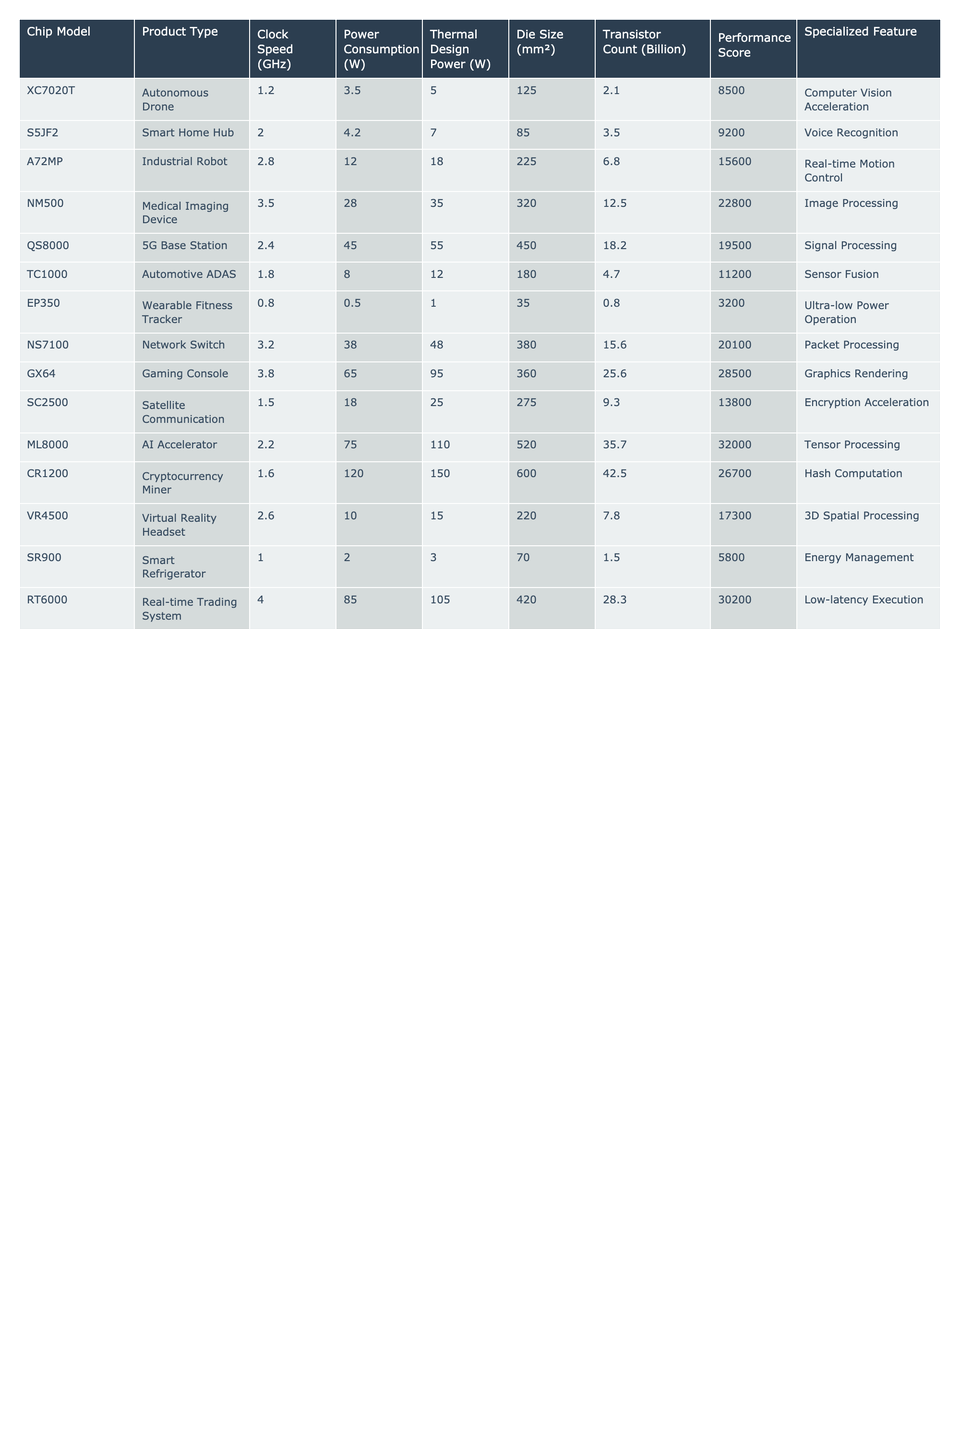What is the highest Performance Score among the chip models? The Performance Score for each chip model can be found in the table. Scanning through the rows, the highest value is 32000 for the ML8000 AI Accelerator.
Answer: 32000 Which chip model has the lowest Power Consumption? Checking the Power Consumption column reveals that the EP350 Wearable Fitness Tracker has the lowest value at 0.5 W.
Answer: 0.5 W How many chip models have a Clock Speed greater than 2.5 GHz? By counting the Clock Speed values in the table, we see that there are three models (NM500 at 3.5 GHz, QS8000 at 2.4 GHz, and GX64 at 3.8 GHz) with speeds over 2.5 GHz. The ones above 2.5 GHz are NM500, QS8000, and GX64.
Answer: 3 Is the Chip Model RT6000 associated with a Specialized Feature related to low-latency execution? The Specialized Feature for RT6000 is indeed Low-latency Execution, confirming that this statement is true.
Answer: Yes What is the average Thermal Design Power for all chip models? Summing the Thermal Design Power values from the table: 5 + 7 + 18 + 35 + 55 + 12 + 1 + 48 + 95 + 25 + 110 + 150 = 516. There are 12 models, so the average is 516 / 12 = 43.
Answer: 43 Which product type has the highest transistor count? Looking at the Transistor Count column, the chip model ML8000 has the highest count at 35.7 billion. Checking all models confirms that no others exceed this count.
Answer: AI Accelerator What is the difference in Thermal Design Power between the chip with the highest and lowest values? The highest Thermal Design Power is 150 W for the CR1200, and the lowest is 1 W for the EP350, so the difference is 150 - 1 = 149.
Answer: 149 W Does the Gaming Console model consume more power than the Smart Home Hub model? Comparing their Power Consumption values shows the Gaming Console consumes 65 W while the Smart Home Hub consumes 4.2 W, indicating that the Gaming Console indeed consumes more power.
Answer: Yes What specialized feature is associated with the Industrial Robot chip model? The Specialized Feature column reveals that the A72MP Industrial Robot has Real-time Motion Control as its associated feature.
Answer: Real-time Motion Control How many total watts are consumed by all chip models combined? Adding Power Consumption values: 3.5 + 4.2 + 12 + 28 + 45 + 8 + 0.5 + 38 + 65 + 18 + 120 + 10 = 353.7 W for all models. There are 12 models, so the total power consumption is 353.7 W.
Answer: 353.7 W 